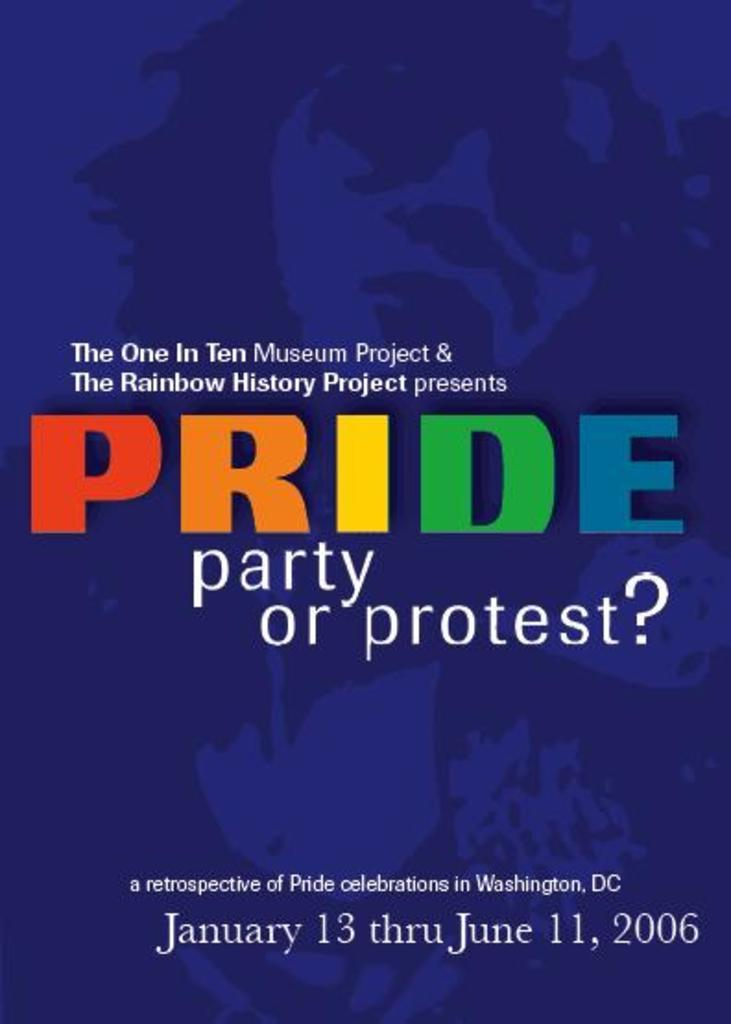<image>
Present a compact description of the photo's key features. A poster advertises The Rainbow History Project presentation of Pride, party or protest. 